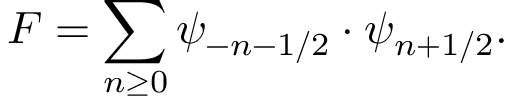Convert formula to latex. <formula><loc_0><loc_0><loc_500><loc_500>F = \sum _ { n \geq 0 } \psi _ { - n - 1 / 2 } \cdot \psi _ { n + 1 / 2 } .</formula> 